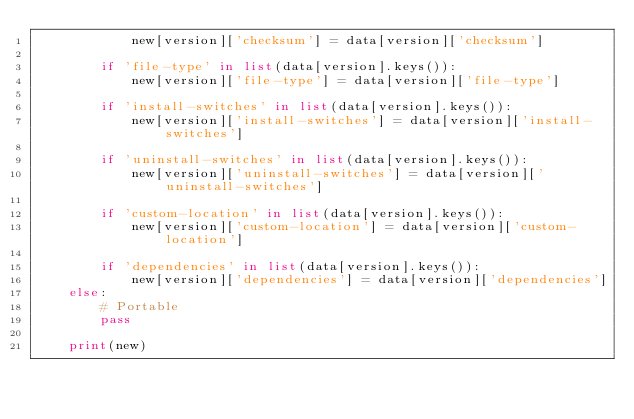Convert code to text. <code><loc_0><loc_0><loc_500><loc_500><_Python_>            new[version]['checksum'] = data[version]['checksum']

        if 'file-type' in list(data[version].keys()):
            new[version]['file-type'] = data[version]['file-type']
        
        if 'install-switches' in list(data[version].keys()):
            new[version]['install-switches'] = data[version]['install-switches']
        
        if 'uninstall-switches' in list(data[version].keys()):
            new[version]['uninstall-switches'] = data[version]['uninstall-switches']
        
        if 'custom-location' in list(data[version].keys()):
            new[version]['custom-location'] = data[version]['custom-location']
      
        if 'dependencies' in list(data[version].keys()):
            new[version]['dependencies'] = data[version]['dependencies']
    else:
        # Portable
        pass

    print(new)
</code> 